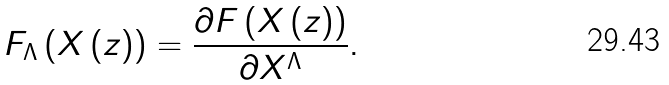<formula> <loc_0><loc_0><loc_500><loc_500>F _ { \Lambda } \left ( X \left ( z \right ) \right ) = \frac { \partial F \left ( X \left ( z \right ) \right ) } { \partial X ^ { \Lambda } } .</formula> 